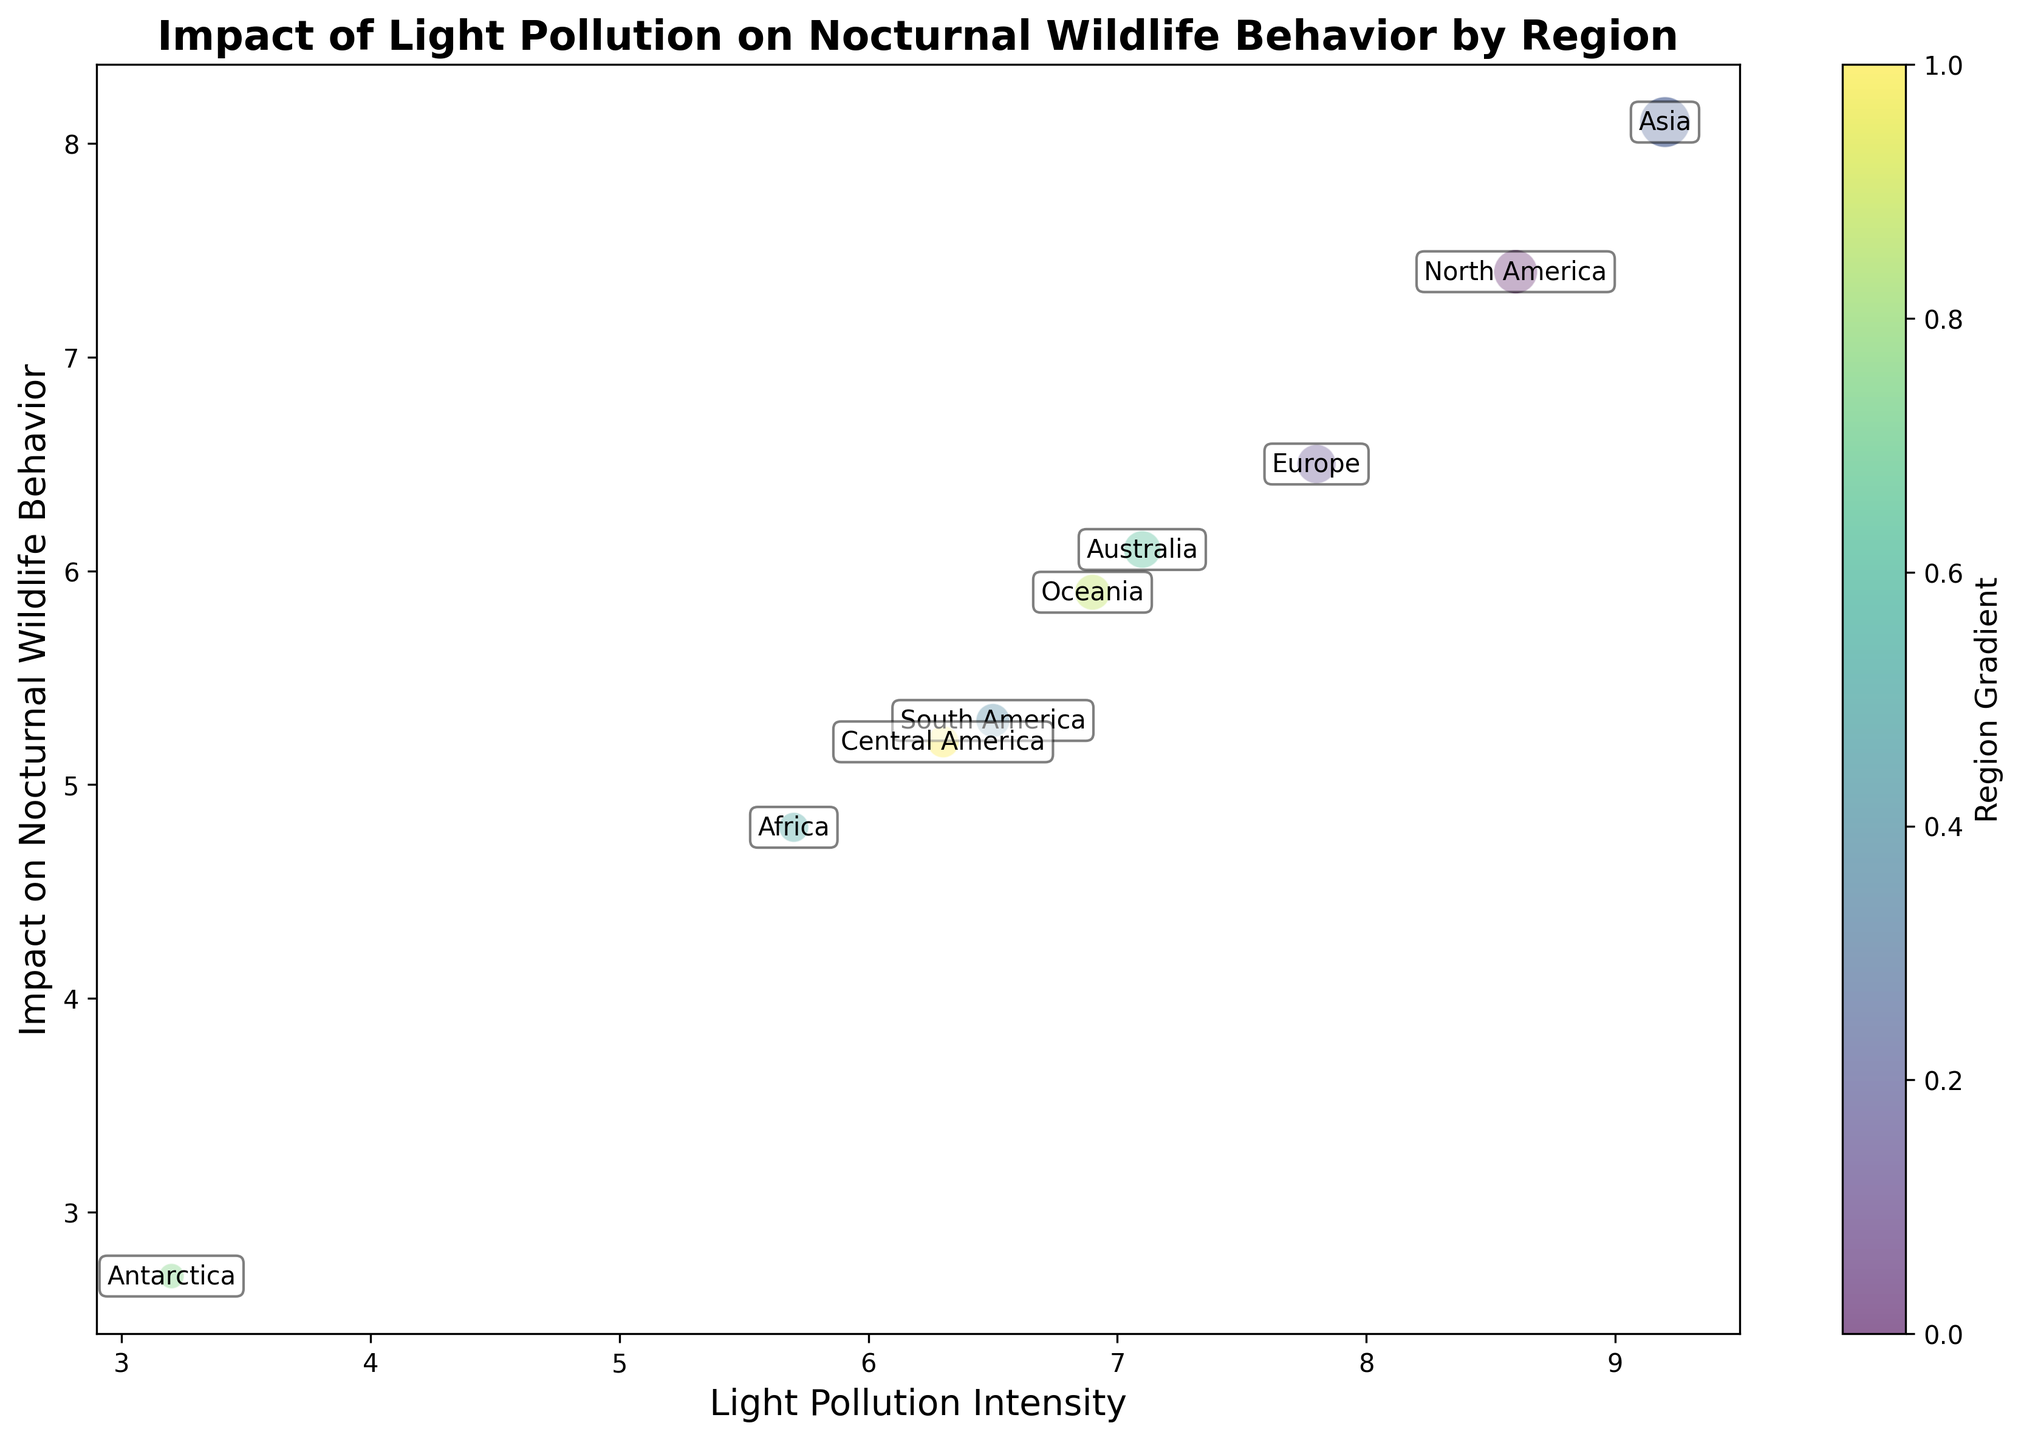Which region experiences the highest light pollution intensity? The light pollution intensity for each region is represented on the x-axis. The highest x-value is 9.2, corresponding to Asia.
Answer: Asia Which region has the lowest impact on nocturnal wildlife behavior? The impact on nocturnal wildlife behavior is depicted on the y-axis. The lowest y-value is 2.7, corresponding to Antarctica.
Answer: Antarctica How does the light pollution intensity in North America compare to Europe? North America's light pollution intensity is 8.6, while Europe's is 7.8. Therefore, North America has a higher light pollution intensity.
Answer: North America is higher What is the difference in the impact on nocturnal wildlife behavior between Africa and Oceania? Africa's impact on nocturnal wildlife behavior is 4.8, and Oceania's is 5.9. The difference is 5.9 - 4.8 = 1.1.
Answer: 1.1 Which region has more data points, Central America or South America? The data points are represented by the bubble size. Central America has 80 data points, while South America has 90 data points.
Answer: South America Is there a region where the light pollution intensity is less than that of Australia but the impact on wildlife is higher? Australia's light pollution intensity (LPI) is 7.1 and its impact on wildlife is 6.1. Asia has an LPI of 9.2 and an impact of 8.1, so no region fits the criteria.
Answer: No Which regions are represented by the most and least data points? The size of the bubbles indicates the number of data points. Asia has the largest bubble (200 data points), and Antarctica has the smallest bubble (50 data points).
Answer: Asia and Antarctica What is the median light pollution intensity among all regions? To find the median, we must order the intensities: 3.2, 5.7, 6.3, 6.5, 6.9, 7.1, 7.8, 8.6, 9.2. The median value (middle value) is 6.9.
Answer: 6.9 How does the impact on nocturnal wildlife behavior in Europe compare to that in Australia? Europe's impact on nocturnal wildlife behavior is 6.5, and Australia's is 6.1. Therefore, Europe's impact is slightly higher.
Answer: Europe is higher 